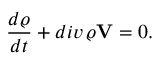<formula> <loc_0><loc_0><loc_500><loc_500>\frac { d \varrho } { d t } + d i v \, \varrho { V } = 0 .</formula> 